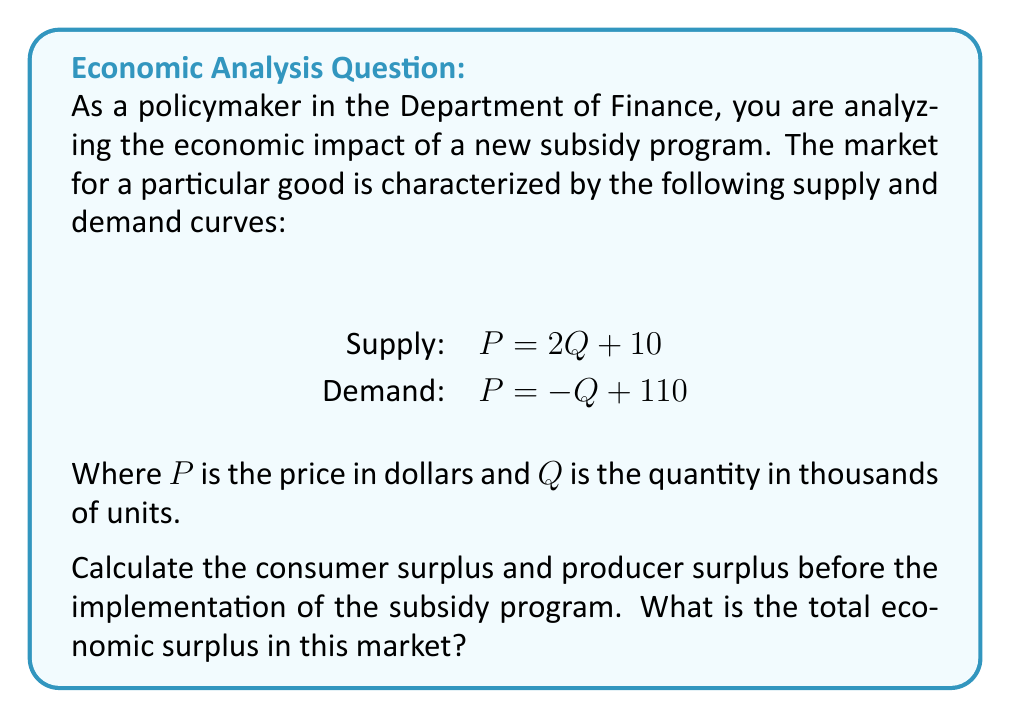Can you solve this math problem? To solve this problem, we need to follow these steps:

1. Find the equilibrium point by equating supply and demand:
   $2Q + 10 = -Q + 110$
   $3Q = 100$
   $Q = \frac{100}{3} \approx 33.33$ thousand units
   
   Substitute this Q into either equation to find P:
   $P = 2(\frac{100}{3}) + 10 = \frac{200}{3} + 10 = \frac{230}{3} \approx 76.67$ dollars

2. Calculate consumer surplus:
   Consumer surplus is the area between the demand curve and the equilibrium price.
   $$CS = \frac{1}{2} * (110 - \frac{230}{3}) * \frac{100}{3} = \frac{1}{2} * \frac{100}{3} * \frac{100}{3} = \frac{5000}{9} \approx 555.56$$

3. Calculate producer surplus:
   Producer surplus is the area between the supply curve and the equilibrium price.
   $$PS = \frac{1}{2} * (\frac{230}{3} - 10) * \frac{100}{3} = \frac{1}{2} * \frac{200}{3} * \frac{100}{3} = \frac{10000}{9} \approx 1111.11$$

4. Calculate total economic surplus:
   Total economic surplus is the sum of consumer surplus and producer surplus.
   $$TES = CS + PS = \frac{5000}{9} + \frac{10000}{9} = \frac{15000}{9} \approx 1666.67$$

[asy]
import graph;
size(200,200);
real f(real x) {return 2x+10;}
real g(real x) {return -x+110;}
draw(graph(f,0,50),blue);
draw(graph(g,0,110),red);
label("Supply",(-5,100),blue);
label("Demand",(55,50),red);
dot((100/3,230/3));
label("Equilibrium",(40,80),black);
xaxis("Quantity (thousands)",BottomTop,LeftTicks);
yaxis("Price ($)",LeftRight,RightTicks);
[/asy]
Answer: The consumer surplus is $\frac{5000}{9} \approx 555.56$, the producer surplus is $\frac{10000}{9} \approx 1111.11$, and the total economic surplus is $\frac{15000}{9} \approx 1666.67$ (all values in thousands of dollars). 